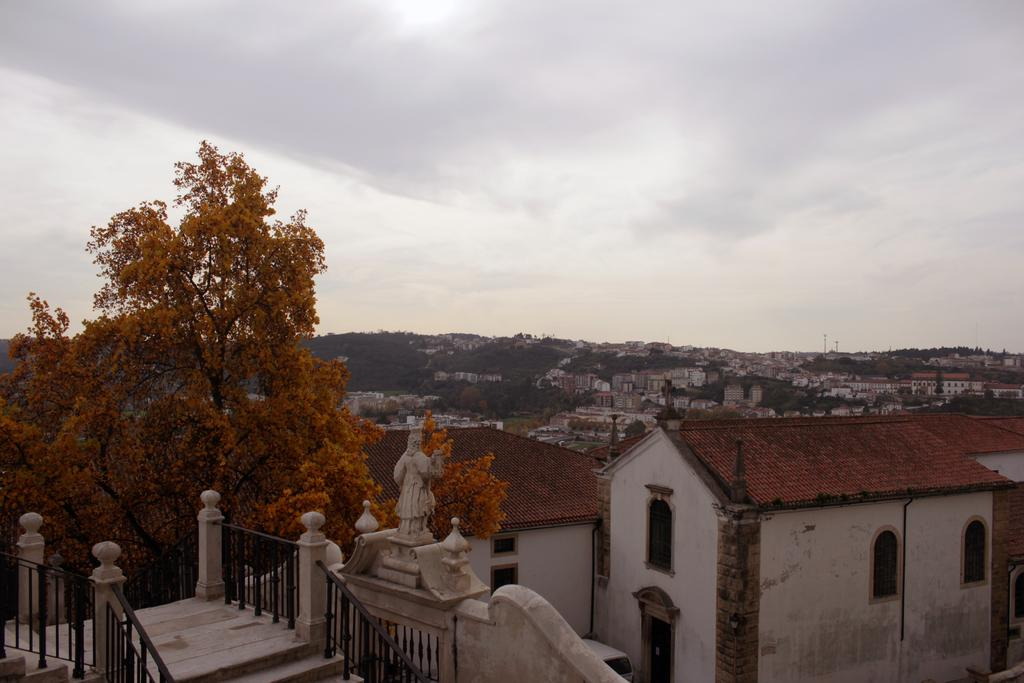What type of structures can be seen in the image? There are buildings in the image. What artistic features are present in the image? There are sculptures in the image. Are there any architectural elements that include stairs and fencing? Yes, there are staircases with fencing in the image. What type of natural elements can be seen in the image? There are trees in the image. What season is depicted in the image? The provided facts do not mention any specific season, so it cannot be determined from the image. 